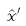<formula> <loc_0><loc_0><loc_500><loc_500>\hat { x } ^ { \prime }</formula> 